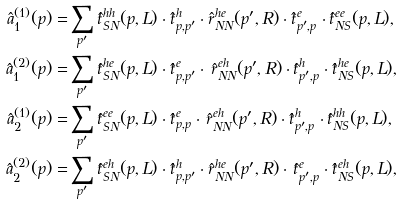Convert formula to latex. <formula><loc_0><loc_0><loc_500><loc_500>\hat { a } _ { 1 } ^ { ( 1 ) } ( p ) = & \sum _ { p ^ { \prime } } \hat { t } _ { S N } ^ { h h } ( p , L ) \cdot \hat { t } ^ { h } _ { p , p ^ { \prime } } \cdot \hat { r } _ { N N } ^ { h e } ( p ^ { \prime } , R ) \cdot \hat { t } ^ { e } _ { p ^ { \prime } , p } \cdot \hat { t } _ { N S } ^ { e e } ( p , L ) , \\ \hat { a } _ { 1 } ^ { ( 2 ) } ( p ) = & \sum _ { p ^ { \prime } } \hat { t } _ { S N } ^ { h e } ( p , L ) \cdot \hat { t } ^ { e } _ { p , p ^ { \prime } } \cdot \, \hat { r } _ { N N } ^ { e h } ( p ^ { \prime } , R ) \cdot \hat { t } ^ { h } _ { p ^ { \prime } , p } \cdot \hat { t } _ { N S } ^ { h e } ( p , L ) , \\ \hat { a } _ { 2 } ^ { ( 1 ) } ( p ) = & \sum _ { p ^ { \prime } } \hat { t } _ { S N } ^ { e e } ( p , L ) \cdot \hat { t } ^ { e } _ { p , p } \cdot \, \hat { r } _ { N N } ^ { e h } ( p ^ { \prime } , R ) \cdot \hat { t } ^ { h } _ { p ^ { \prime } , p } \cdot \hat { t } _ { N S } ^ { h h } ( p , L ) , \\ \hat { a } _ { 2 } ^ { ( 2 ) } ( p ) = & \sum _ { p ^ { \prime } } \hat { t } _ { S N } ^ { e h } ( p , L ) \cdot \hat { t } ^ { h } _ { p , p ^ { \prime } } \cdot \hat { r } _ { N N } ^ { h e } ( p ^ { \prime } , R ) \cdot \, \hat { t } ^ { e } _ { p ^ { \prime } , p } \cdot \hat { t } _ { N S } ^ { e h } ( p , L ) ,</formula> 